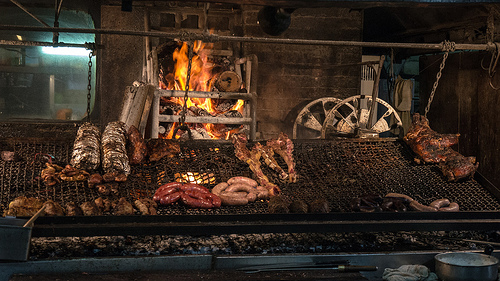<image>
Can you confirm if the fire is behind the turkey leg? Yes. From this viewpoint, the fire is positioned behind the turkey leg, with the turkey leg partially or fully occluding the fire. Where is the fire in relation to the meat? Is it above the meat? No. The fire is not positioned above the meat. The vertical arrangement shows a different relationship. 